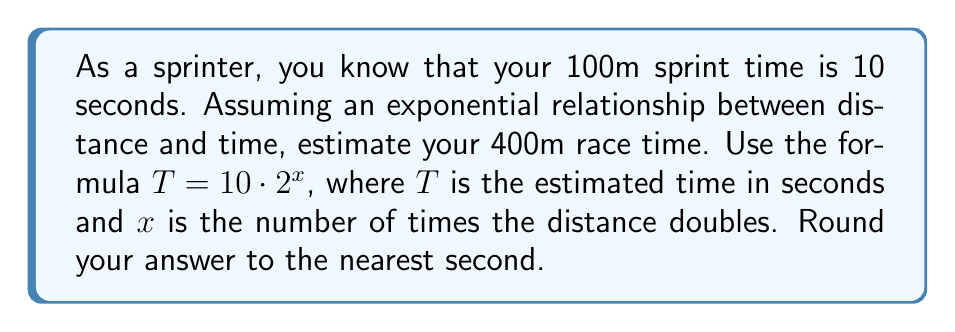Help me with this question. To solve this problem, we need to follow these steps:

1. Determine how many times the distance doubles from 100m to 400m.
2. Use the given formula to calculate the estimated time.
3. Round the result to the nearest second.

Step 1: Doubling the distance
100m → 200m (1st doubling)
200m → 400m (2nd doubling)
So, the distance doubles twice ($x = 2$).

Step 2: Calculate the estimated time
Using the formula $T = 10 \cdot 2^x$, we substitute $x = 2$:

$$T = 10 \cdot 2^2$$
$$T = 10 \cdot 4$$
$$T = 40$$

Step 3: Rounding
The result is already a whole number, so no rounding is necessary.

This exponential model suggests that as the race distance increases, the time increases at a faster rate than a linear relationship would predict, reflecting the increased fatigue and energy expenditure in longer sprints.
Answer: 40 seconds 